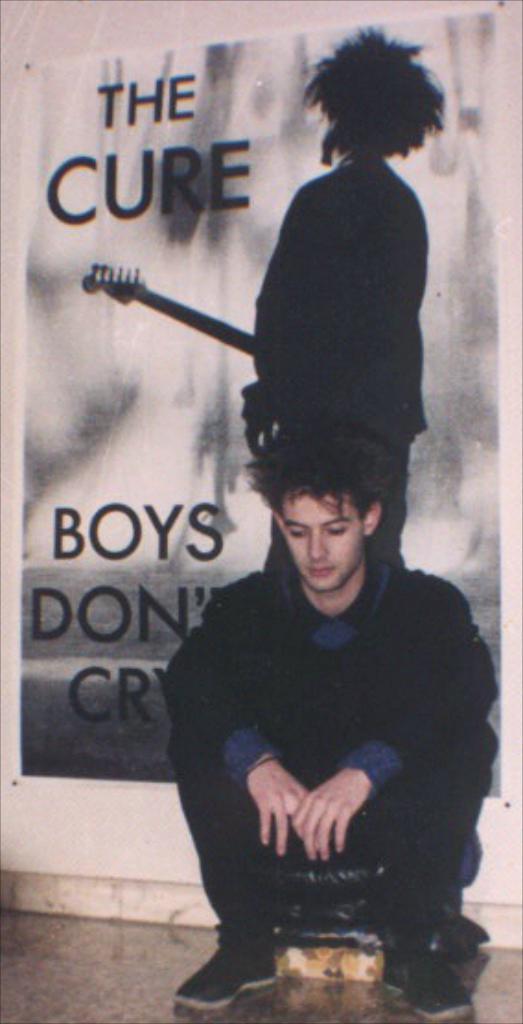How would you summarize this image in a sentence or two? In this game we can see a person sitting. On the backside we can see a board with the picture of a person and some text on it which is pinned on a wall. 